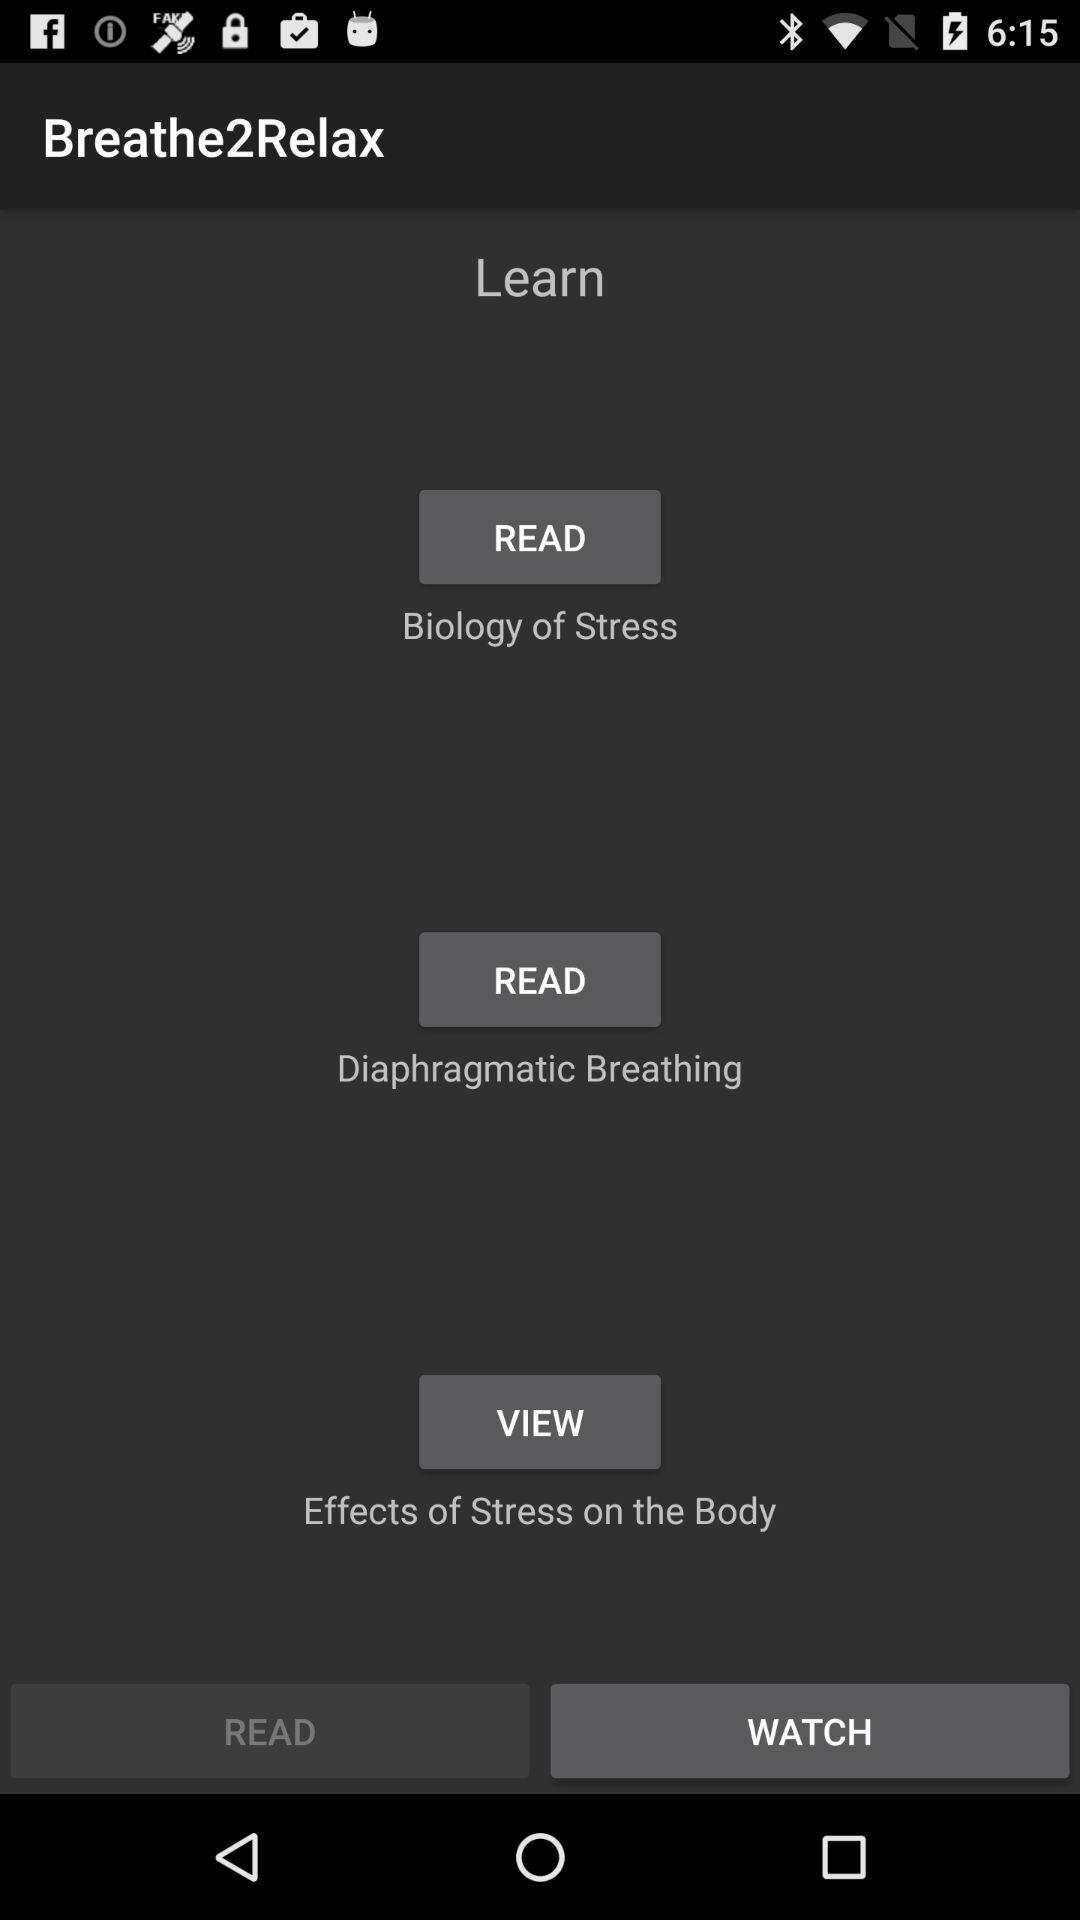What is the application name? The application name is "Breathe2Relax". 